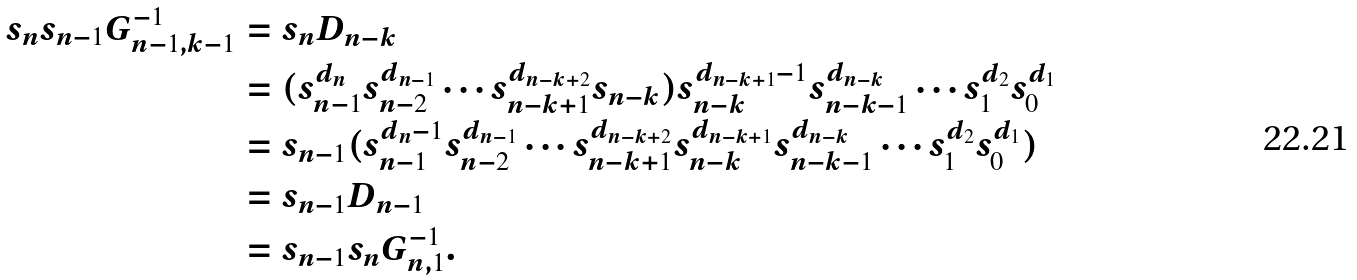Convert formula to latex. <formula><loc_0><loc_0><loc_500><loc_500>s _ { n } s _ { n - 1 } G _ { n - 1 , k - 1 } ^ { - 1 } & = s _ { n } D _ { n - k } \\ & = ( s _ { n - 1 } ^ { d _ { n } } s _ { n - 2 } ^ { d _ { n - 1 } } \cdots s _ { n - k + 1 } ^ { d _ { n - k + 2 } } s _ { n - k } ) s _ { n - k } ^ { d _ { n - k + 1 } - 1 } s _ { n - k - 1 } ^ { d _ { n - k } } \cdots s _ { 1 } ^ { d _ { 2 } } s _ { 0 } ^ { d _ { 1 } } \\ & = s _ { n - 1 } ( s _ { n - 1 } ^ { d _ { n } - 1 } s _ { n - 2 } ^ { d _ { n - 1 } } \cdots s _ { n - k + 1 } ^ { d _ { n - k + 2 } } s _ { n - k } ^ { d _ { n - k + 1 } } s _ { n - k - 1 } ^ { d _ { n - k } } \cdots s _ { 1 } ^ { d _ { 2 } } s _ { 0 } ^ { d _ { 1 } } ) \\ & = s _ { n - 1 } D _ { n - 1 } \\ & = s _ { n - 1 } s _ { n } G _ { n , 1 } ^ { - 1 } .</formula> 